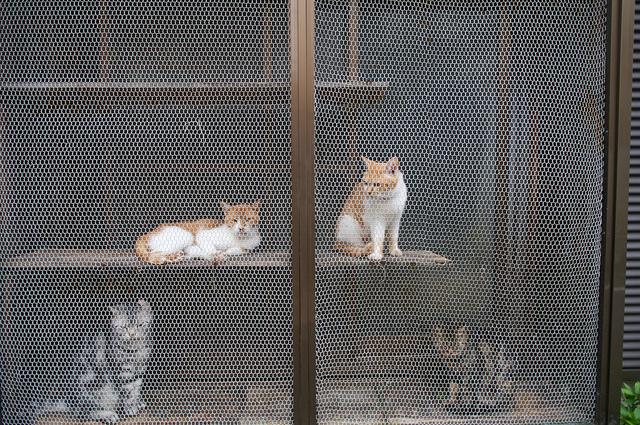How many of the animals are sitting?
Be succinct. 3. Are these animals domesticated?
Give a very brief answer. Yes. How many are white and orange?
Be succinct. 2. 